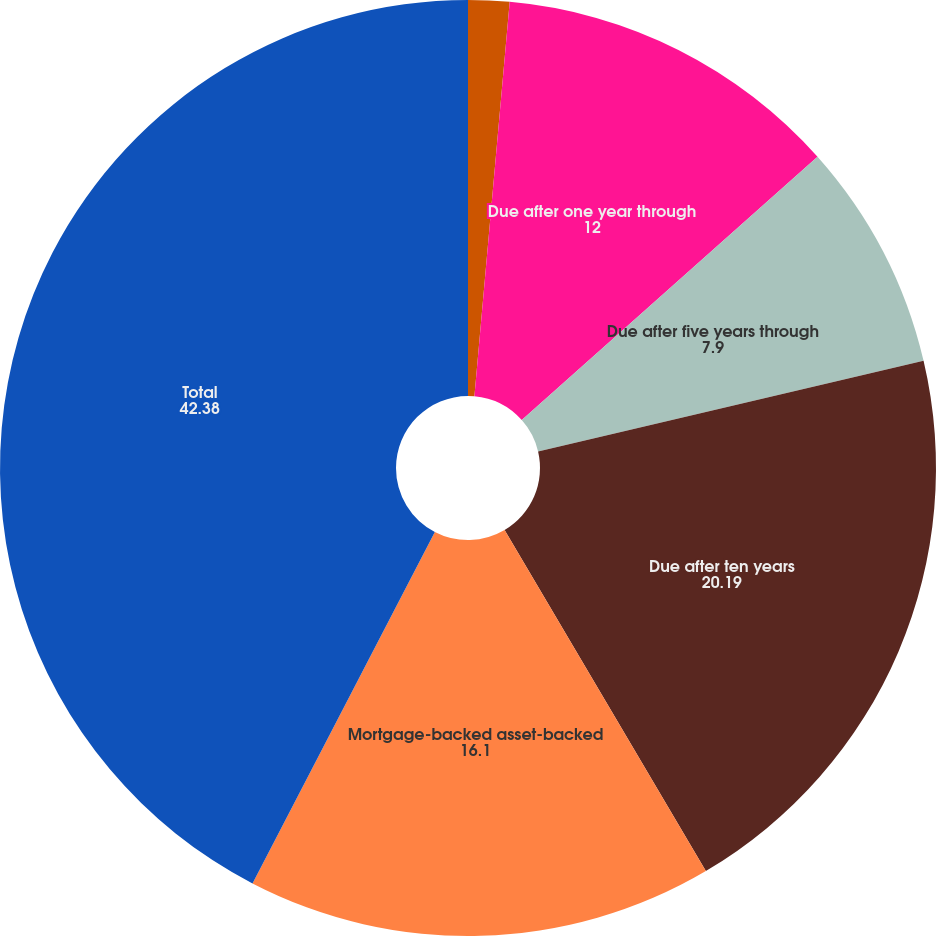<chart> <loc_0><loc_0><loc_500><loc_500><pie_chart><fcel>Due in one year or less<fcel>Due after one year through<fcel>Due after five years through<fcel>Due after ten years<fcel>Mortgage-backed asset-backed<fcel>Total<nl><fcel>1.42%<fcel>12.0%<fcel>7.9%<fcel>20.19%<fcel>16.1%<fcel>42.38%<nl></chart> 